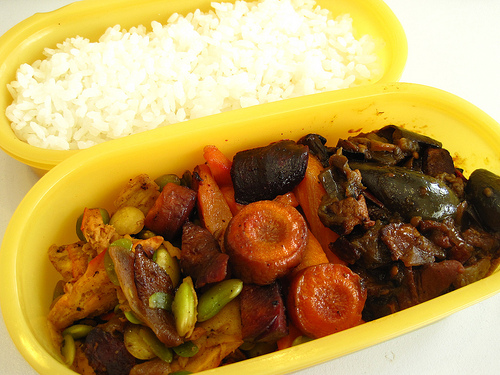<image>
Is the rice to the left of the pea? No. The rice is not to the left of the pea. From this viewpoint, they have a different horizontal relationship. 